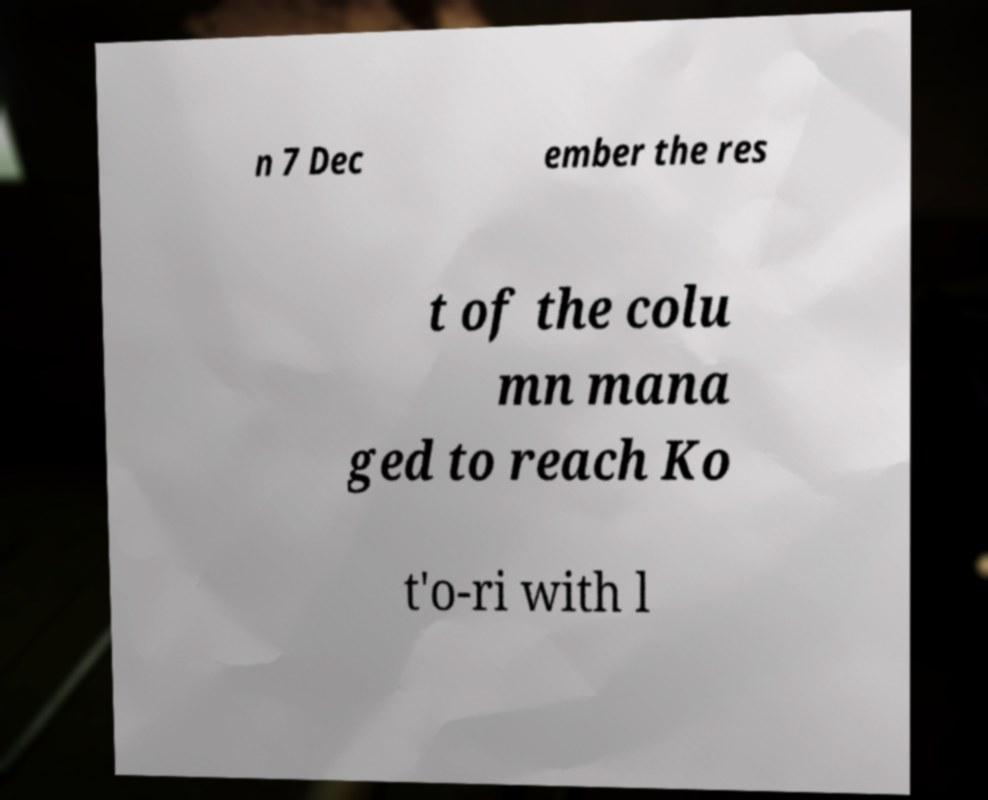Could you assist in decoding the text presented in this image and type it out clearly? n 7 Dec ember the res t of the colu mn mana ged to reach Ko t'o-ri with l 